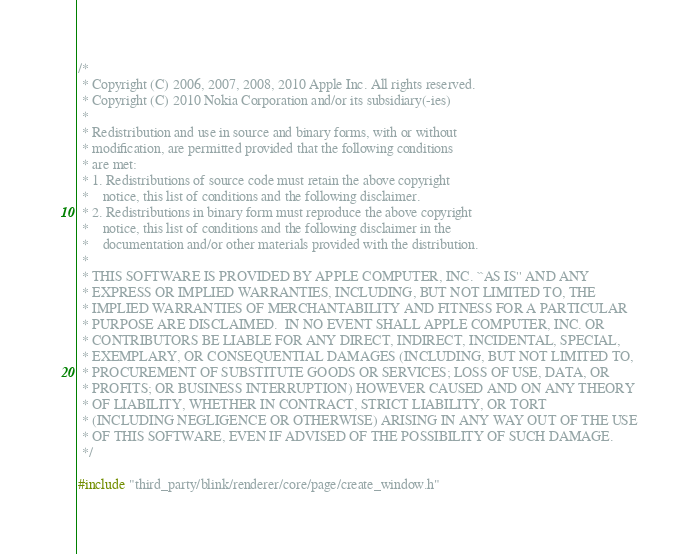<code> <loc_0><loc_0><loc_500><loc_500><_C++_>/*
 * Copyright (C) 2006, 2007, 2008, 2010 Apple Inc. All rights reserved.
 * Copyright (C) 2010 Nokia Corporation and/or its subsidiary(-ies)
 *
 * Redistribution and use in source and binary forms, with or without
 * modification, are permitted provided that the following conditions
 * are met:
 * 1. Redistributions of source code must retain the above copyright
 *    notice, this list of conditions and the following disclaimer.
 * 2. Redistributions in binary form must reproduce the above copyright
 *    notice, this list of conditions and the following disclaimer in the
 *    documentation and/or other materials provided with the distribution.
 *
 * THIS SOFTWARE IS PROVIDED BY APPLE COMPUTER, INC. ``AS IS'' AND ANY
 * EXPRESS OR IMPLIED WARRANTIES, INCLUDING, BUT NOT LIMITED TO, THE
 * IMPLIED WARRANTIES OF MERCHANTABILITY AND FITNESS FOR A PARTICULAR
 * PURPOSE ARE DISCLAIMED.  IN NO EVENT SHALL APPLE COMPUTER, INC. OR
 * CONTRIBUTORS BE LIABLE FOR ANY DIRECT, INDIRECT, INCIDENTAL, SPECIAL,
 * EXEMPLARY, OR CONSEQUENTIAL DAMAGES (INCLUDING, BUT NOT LIMITED TO,
 * PROCUREMENT OF SUBSTITUTE GOODS OR SERVICES; LOSS OF USE, DATA, OR
 * PROFITS; OR BUSINESS INTERRUPTION) HOWEVER CAUSED AND ON ANY THEORY
 * OF LIABILITY, WHETHER IN CONTRACT, STRICT LIABILITY, OR TORT
 * (INCLUDING NEGLIGENCE OR OTHERWISE) ARISING IN ANY WAY OUT OF THE USE
 * OF THIS SOFTWARE, EVEN IF ADVISED OF THE POSSIBILITY OF SUCH DAMAGE.
 */

#include "third_party/blink/renderer/core/page/create_window.h"
</code> 